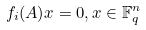<formula> <loc_0><loc_0><loc_500><loc_500>f _ { i } ( A ) x = 0 , x \in \mathbb { F } _ { q } ^ { n }</formula> 